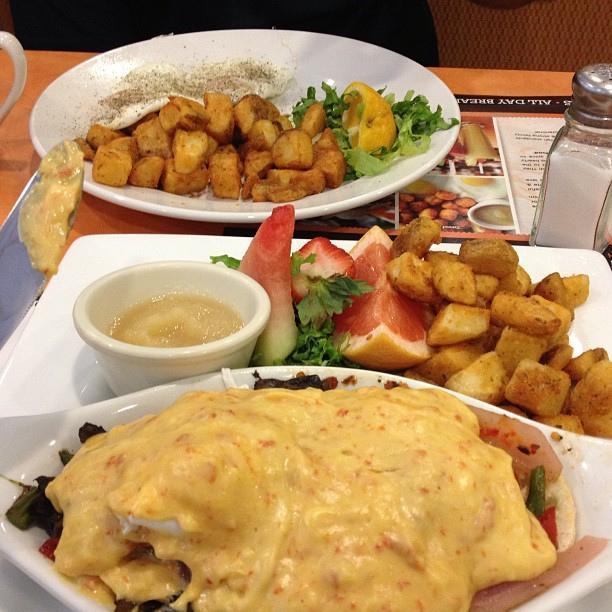How many bowls are there?
Give a very brief answer. 2. 